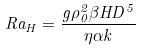<formula> <loc_0><loc_0><loc_500><loc_500>R a _ { H } = \frac { g \rho _ { 0 } ^ { 2 } \beta H D ^ { 5 } } { \eta \alpha k }</formula> 